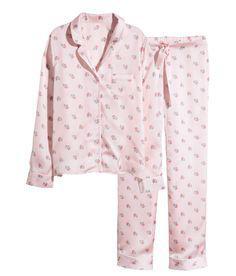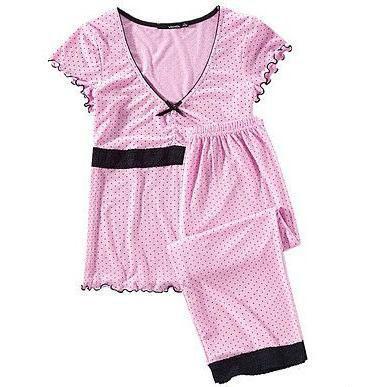The first image is the image on the left, the second image is the image on the right. Assess this claim about the two images: "Each image contains one sleepwear outfit consisting of a patterned top and matching pants, but one outfit has long sleeves while the other has short ruffled sleeves.". Correct or not? Answer yes or no. Yes. The first image is the image on the left, the second image is the image on the right. Considering the images on both sides, is "there is a single pair of pajamas with short sleeves and long pants" valid? Answer yes or no. Yes. 